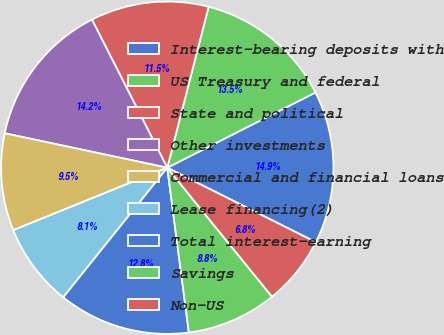Convert chart. <chart><loc_0><loc_0><loc_500><loc_500><pie_chart><fcel>Interest-bearing deposits with<fcel>US Treasury and federal<fcel>State and political<fcel>Other investments<fcel>Commercial and financial loans<fcel>Lease financing(2)<fcel>Total interest-earning<fcel>Savings<fcel>Non-US<nl><fcel>14.87%<fcel>13.52%<fcel>11.49%<fcel>14.19%<fcel>9.46%<fcel>8.1%<fcel>12.84%<fcel>8.78%<fcel>6.75%<nl></chart> 